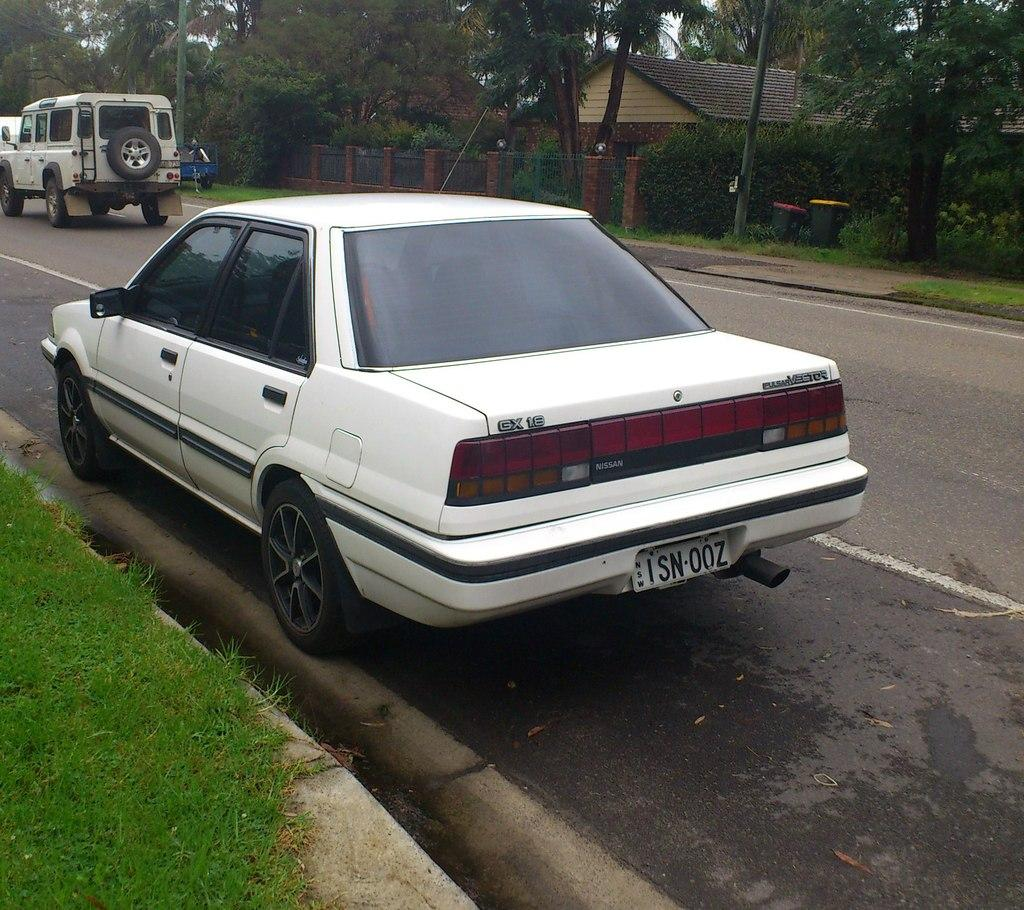What can be seen on the road in the image? There are vehicles parked on the road in the image. What is visible in the background of the image? In the background of the image, there is a fence, a building with a roof, a group of trees, and trash bins. What type of wool is being traded in the image? There is no wool or trade activity present in the image. 